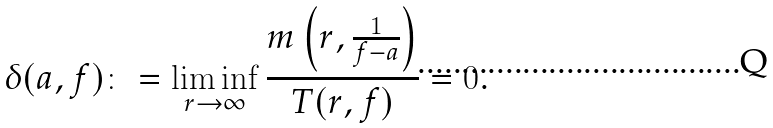Convert formula to latex. <formula><loc_0><loc_0><loc_500><loc_500>\delta ( a , f ) \colon = \liminf _ { r \rightarrow \infty } \frac { m \left ( r , \frac { 1 } { f - a } \right ) } { T ( r , f ) } = 0 .</formula> 